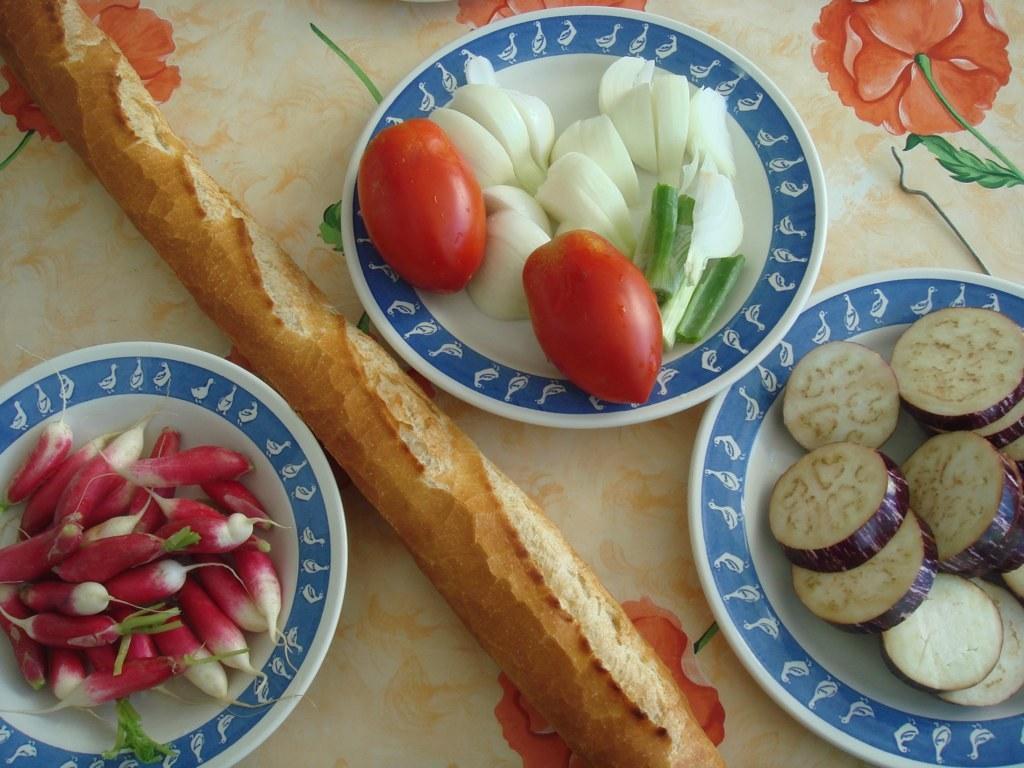Please provide a concise description of this image. In this picture I can observe some vegetables placed in the plate. The plates are in blue and white colors I can observe tomatoes in the plate. 